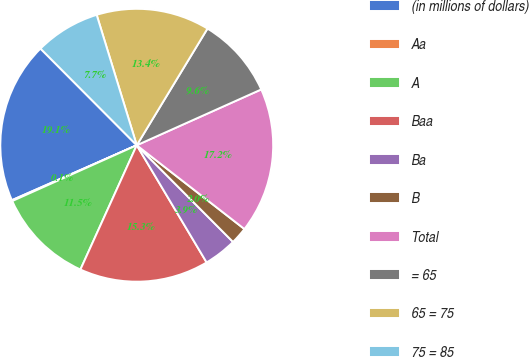<chart> <loc_0><loc_0><loc_500><loc_500><pie_chart><fcel>(in millions of dollars)<fcel>Aa<fcel>A<fcel>Baa<fcel>Ba<fcel>B<fcel>Total<fcel>= 65<fcel>65 = 75<fcel>75 = 85<nl><fcel>19.13%<fcel>0.11%<fcel>11.52%<fcel>15.33%<fcel>3.91%<fcel>2.01%<fcel>17.23%<fcel>9.62%<fcel>13.42%<fcel>7.72%<nl></chart> 